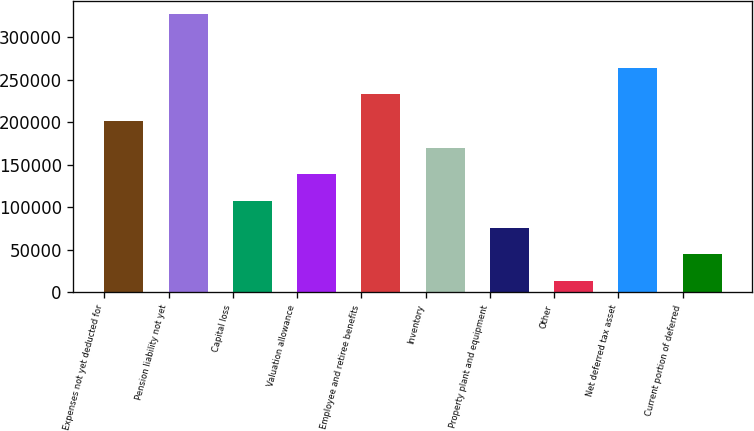Convert chart to OTSL. <chart><loc_0><loc_0><loc_500><loc_500><bar_chart><fcel>Expenses not yet deducted for<fcel>Pension liability not yet<fcel>Capital loss<fcel>Valuation allowance<fcel>Employee and retiree benefits<fcel>Inventory<fcel>Property plant and equipment<fcel>Other<fcel>Net deferred tax asset<fcel>Current portion of deferred<nl><fcel>201385<fcel>326808<fcel>107317<fcel>138673<fcel>232741<fcel>170029<fcel>75961.6<fcel>13250<fcel>264096<fcel>44605.8<nl></chart> 